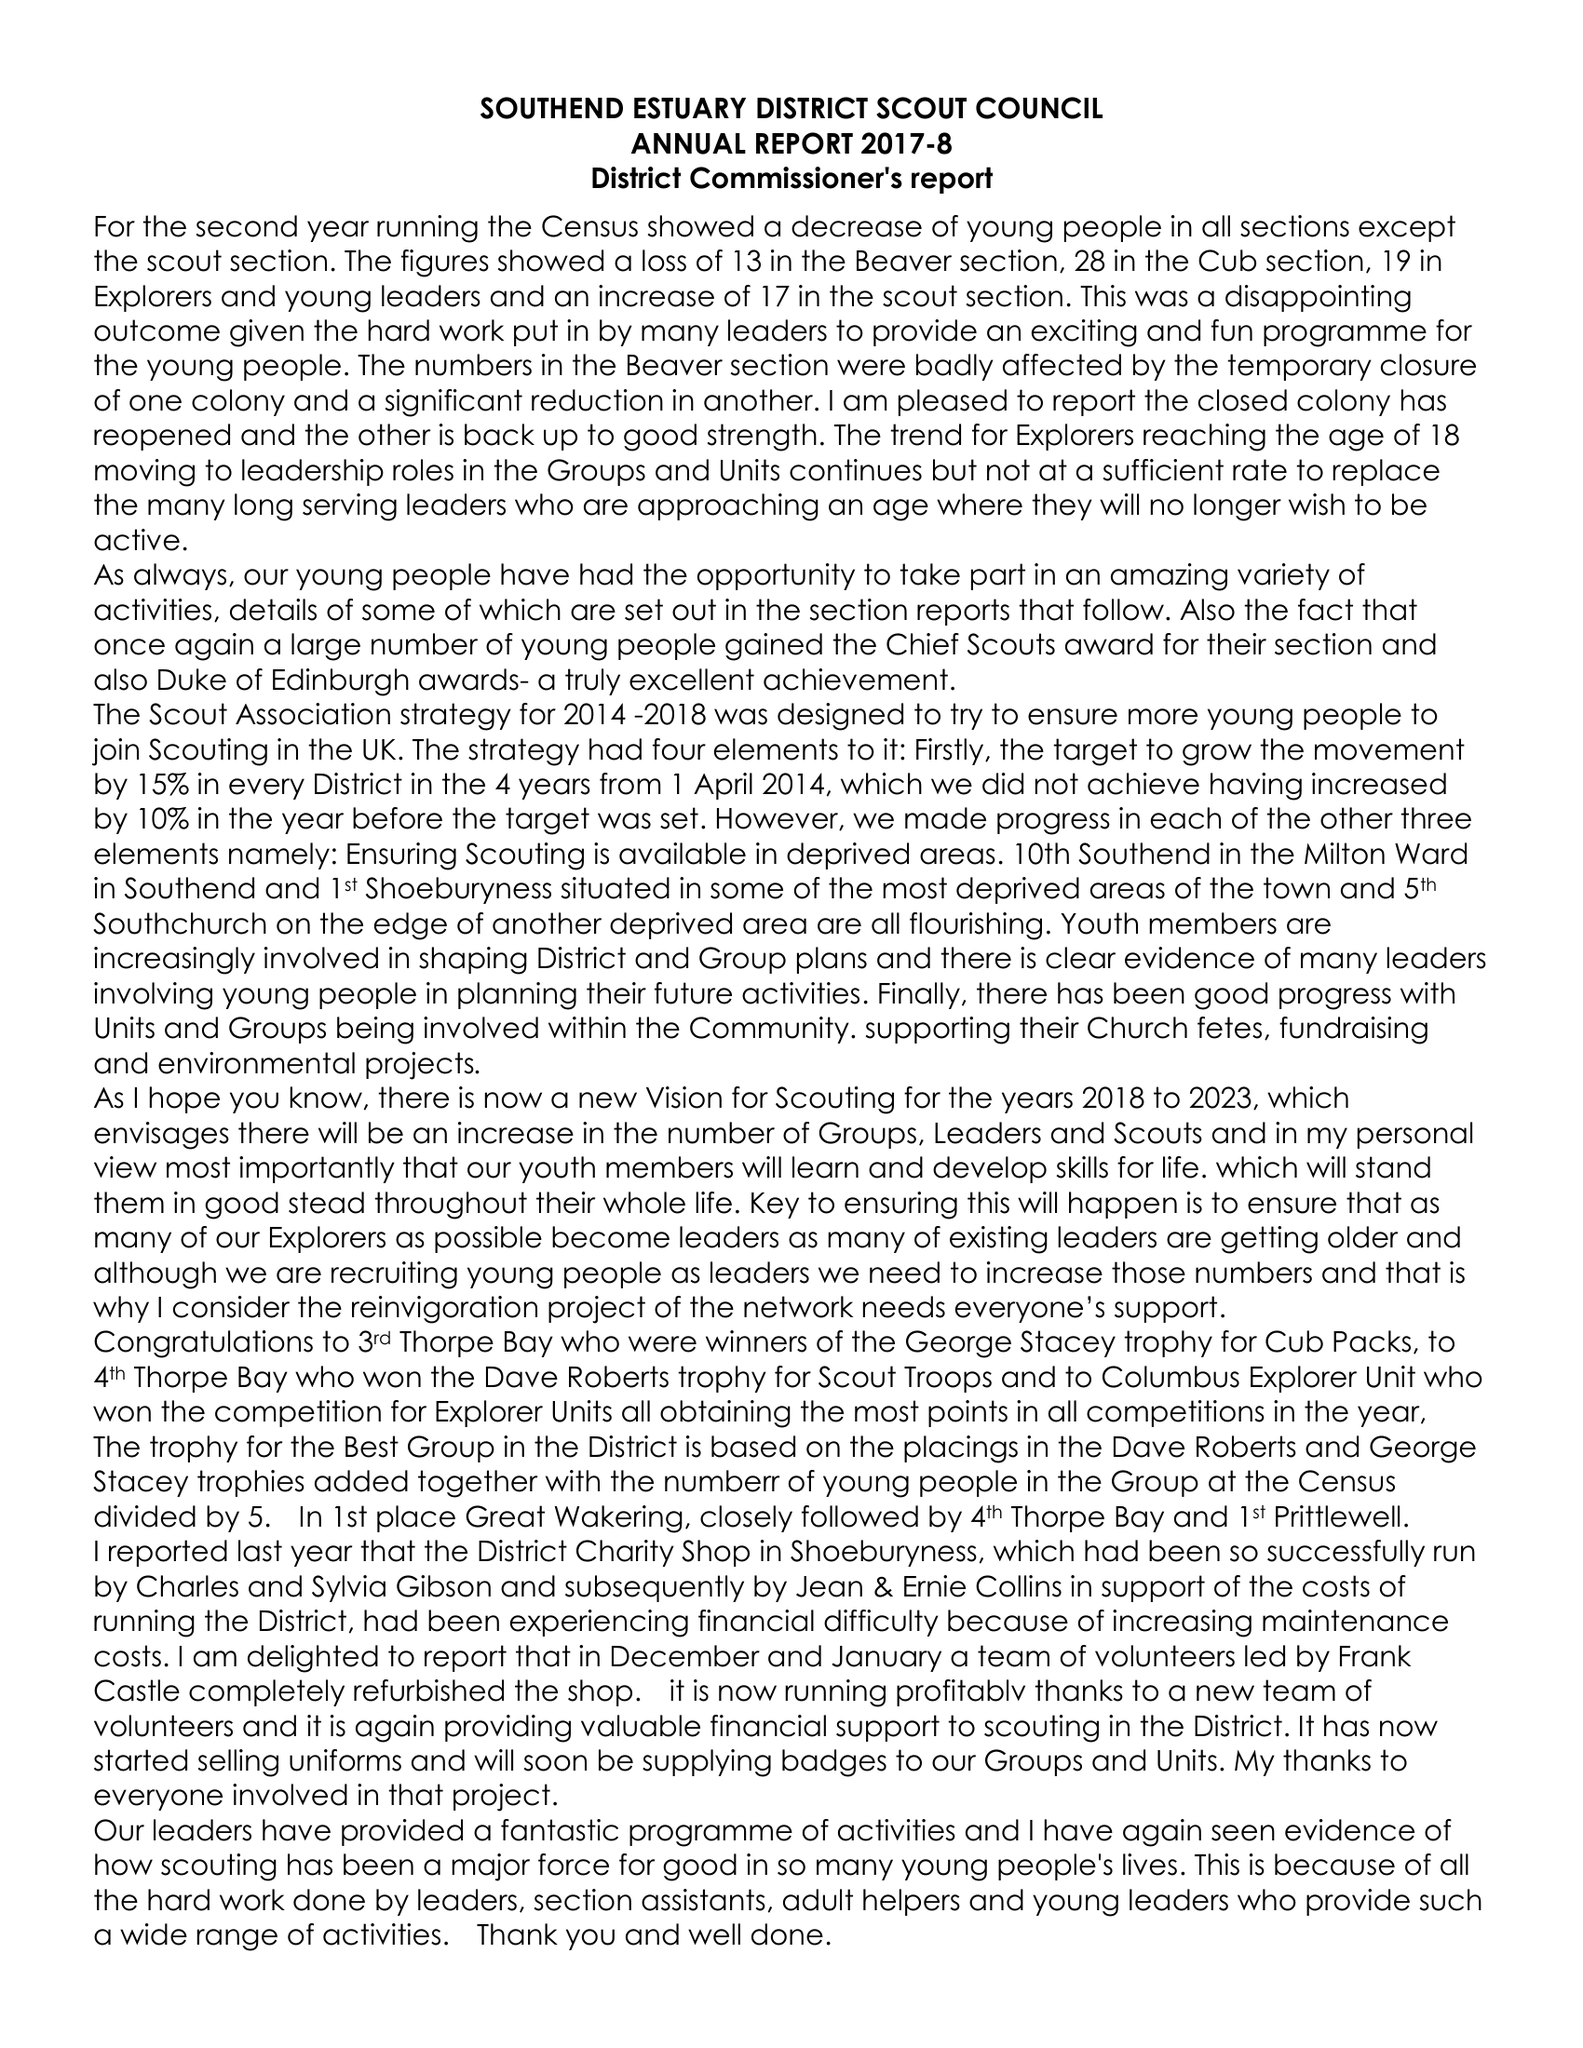What is the value for the income_annually_in_british_pounds?
Answer the question using a single word or phrase. 104767.00 